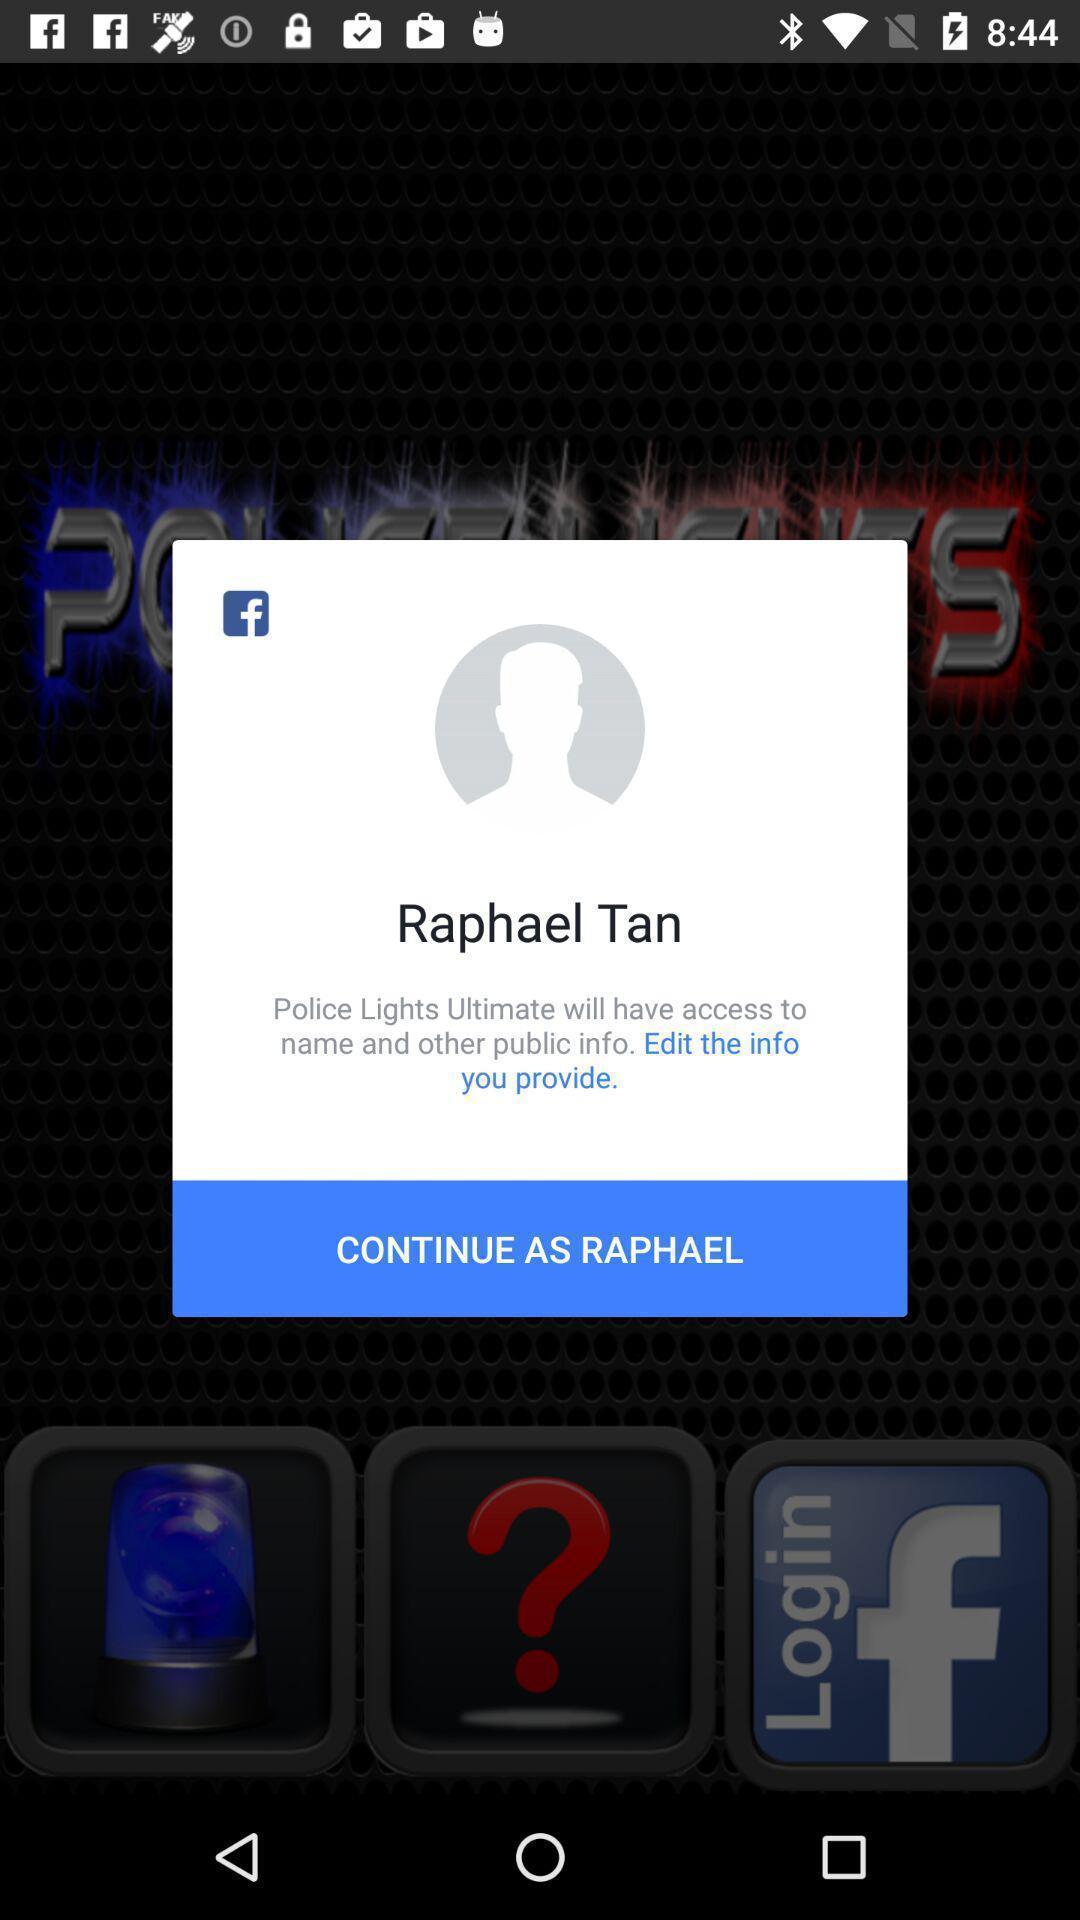Describe the content in this image. Pop-up window showing a profile to continue with the app. 